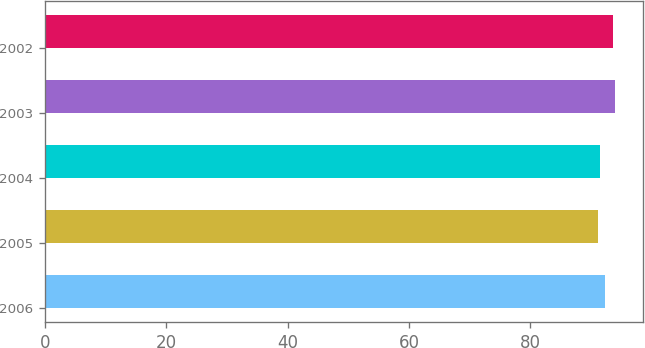Convert chart. <chart><loc_0><loc_0><loc_500><loc_500><bar_chart><fcel>2006<fcel>2005<fcel>2004<fcel>2003<fcel>2002<nl><fcel>92.2<fcel>91.2<fcel>91.5<fcel>93.9<fcel>93.6<nl></chart> 